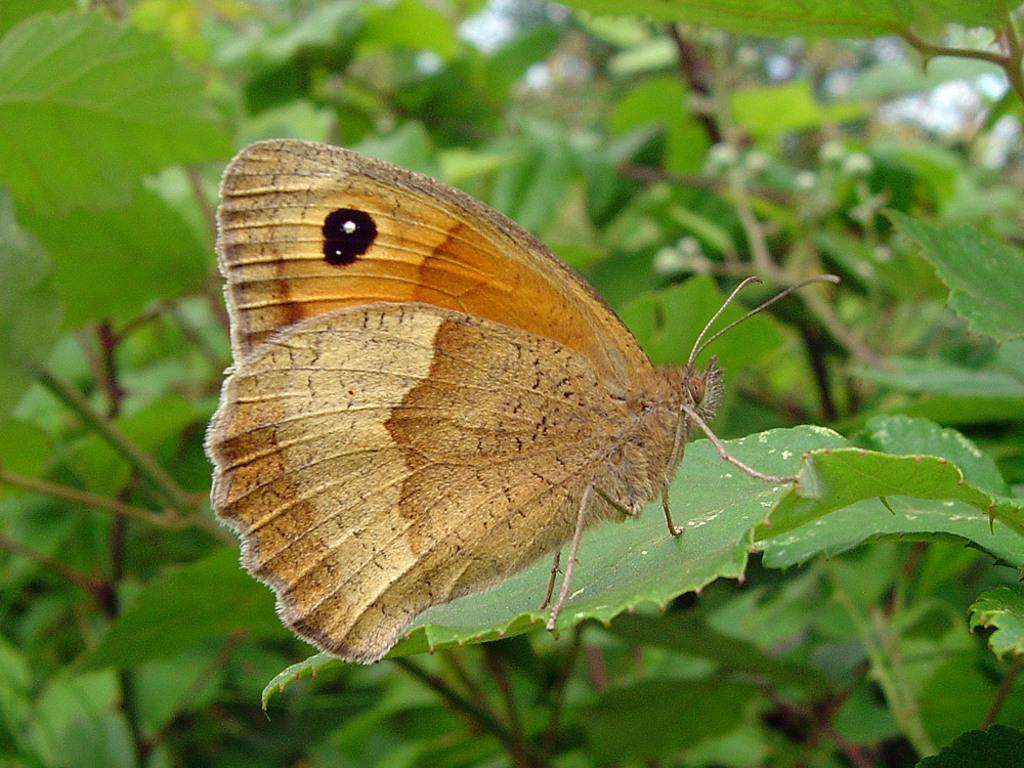What type of insect is on the leaf in the image? There is a brown butterfly on a leaf in the image. What is the butterfly sitting on? The butterfly is sitting on a leaf. What can be seen in the background of the image? There are plants visible in the background. What type of furniture is visible in the image? There is no furniture present in the image; it features a brown butterfly on a leaf with plants in the background. 